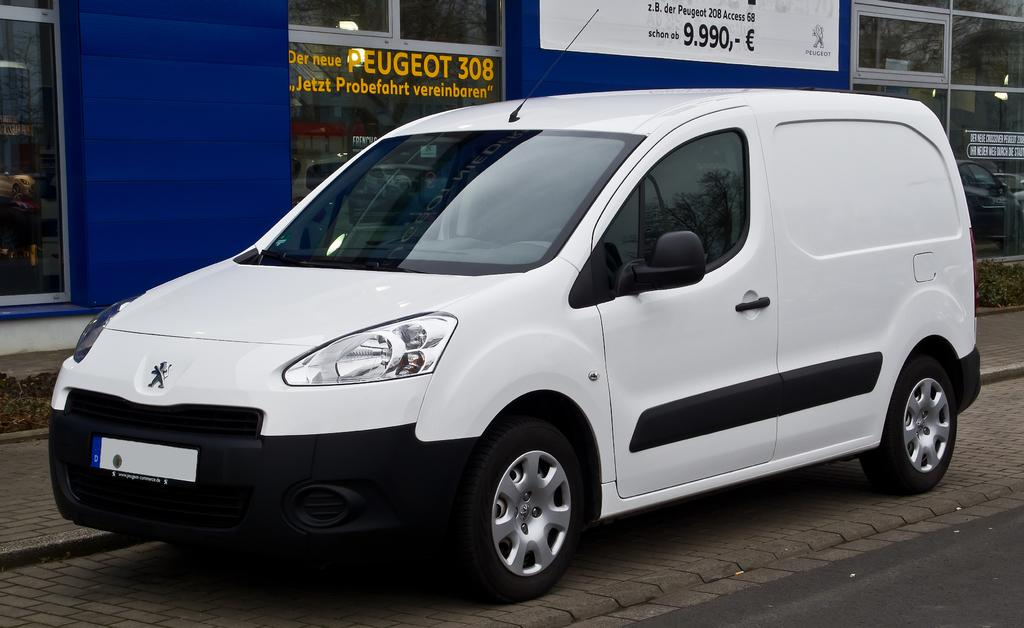<image>
Share a concise interpretation of the image provided. A white van is parked by a building that says Peugeot 308 on the window. 